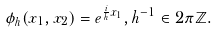<formula> <loc_0><loc_0><loc_500><loc_500>\phi _ { h } ( x _ { 1 } , x _ { 2 } ) = e ^ { \frac { i } h x _ { 1 } } , h ^ { - 1 } \in 2 \pi \mathbb { Z } .</formula> 